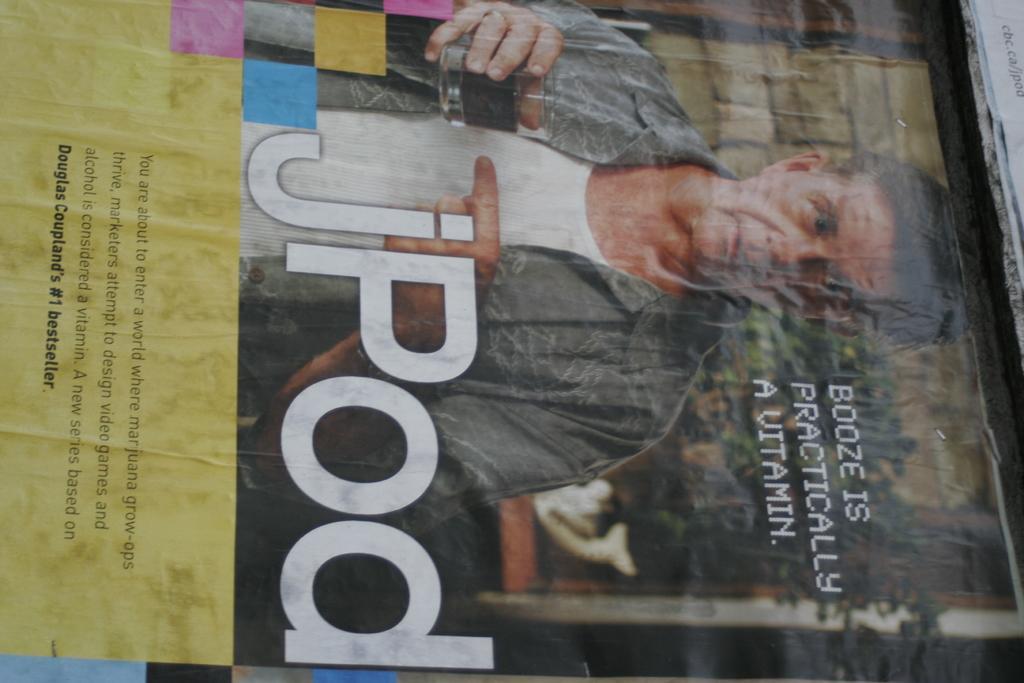How would you summarize this image in a sentence or two? In this image there is a poster. Poster is having a person image and some text on it. Person is wearing a jacket and he is holding a glass in his hand. Glass is filled with drink. Left side of image there is some text. 